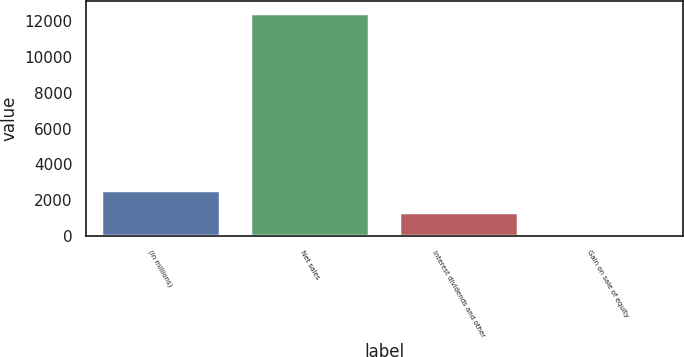Convert chart. <chart><loc_0><loc_0><loc_500><loc_500><bar_chart><fcel>(in millions)<fcel>Net sales<fcel>Interest dividends and other<fcel>Gain on sale of equity<nl><fcel>2576.8<fcel>12480<fcel>1338.9<fcel>101<nl></chart> 